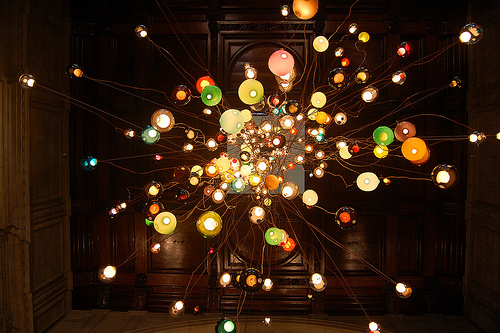<image>
Is the fruit on the plate? No. The fruit is not positioned on the plate. They may be near each other, but the fruit is not supported by or resting on top of the plate. 